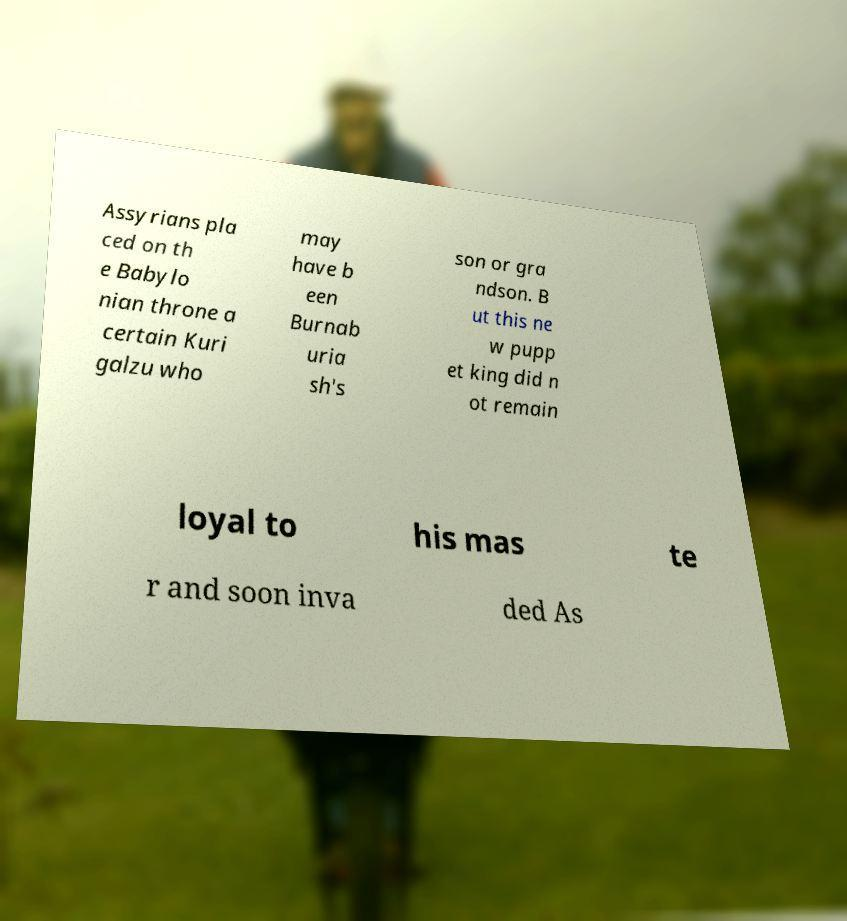Could you assist in decoding the text presented in this image and type it out clearly? Assyrians pla ced on th e Babylo nian throne a certain Kuri galzu who may have b een Burnab uria sh's son or gra ndson. B ut this ne w pupp et king did n ot remain loyal to his mas te r and soon inva ded As 